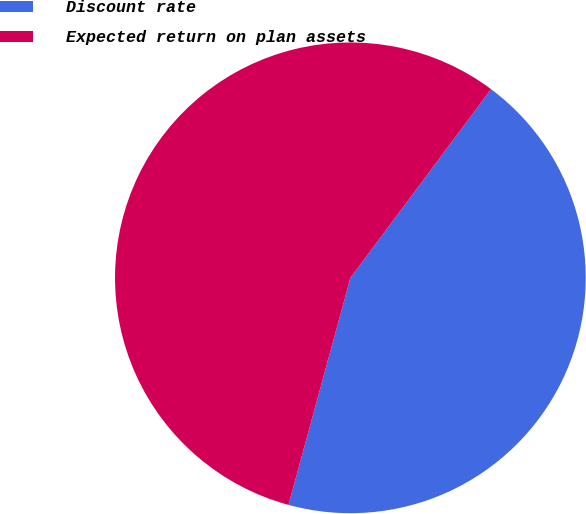<chart> <loc_0><loc_0><loc_500><loc_500><pie_chart><fcel>Discount rate<fcel>Expected return on plan assets<nl><fcel>44.04%<fcel>55.96%<nl></chart> 